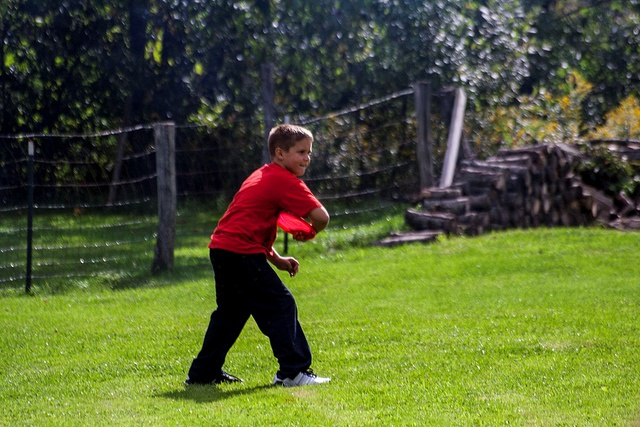Describe the objects in this image and their specific colors. I can see people in black, maroon, brown, and gray tones and frisbee in black, red, and maroon tones in this image. 